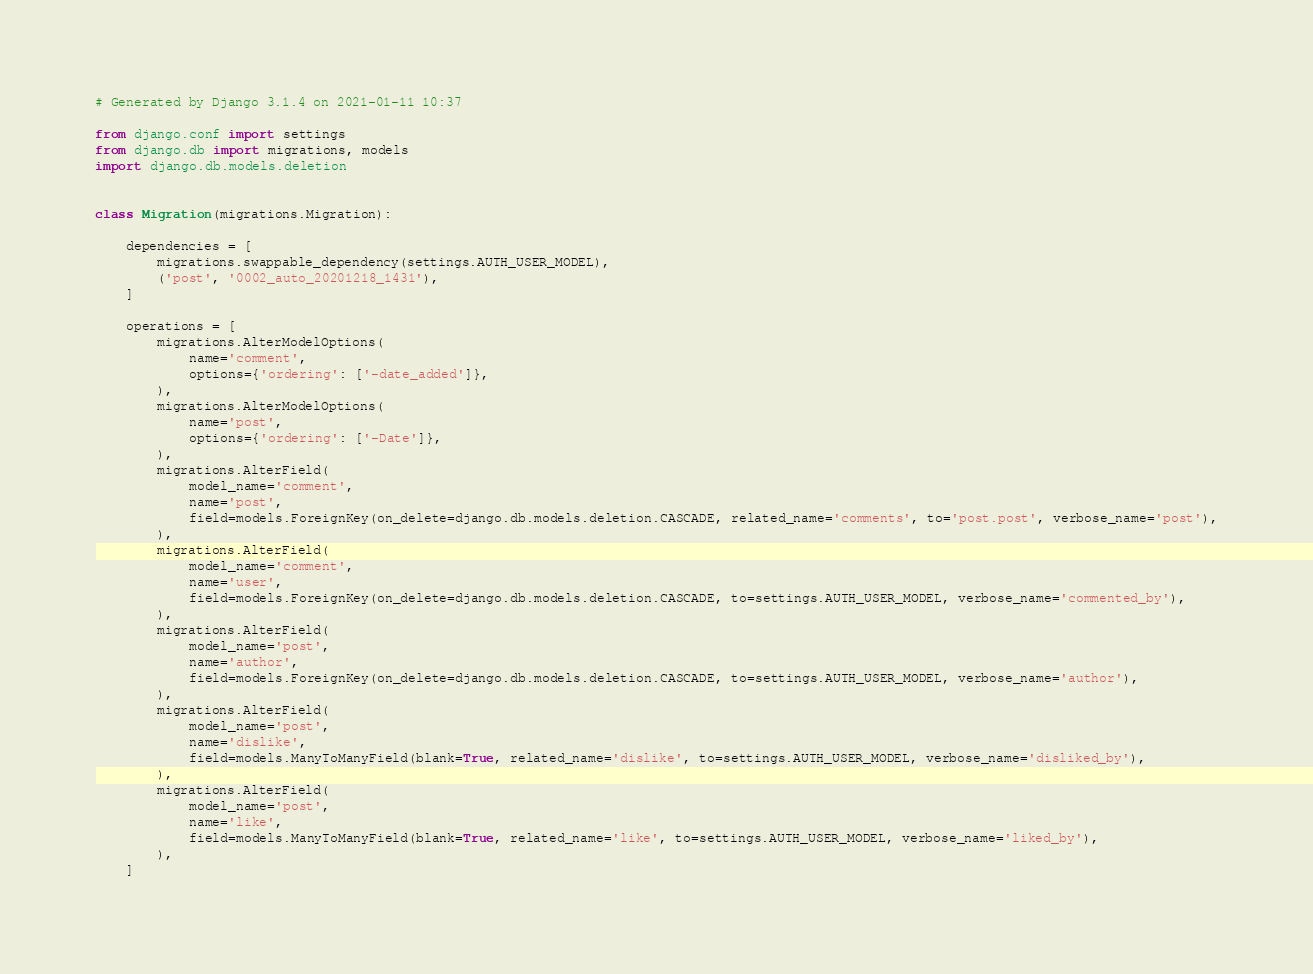<code> <loc_0><loc_0><loc_500><loc_500><_Python_># Generated by Django 3.1.4 on 2021-01-11 10:37

from django.conf import settings
from django.db import migrations, models
import django.db.models.deletion


class Migration(migrations.Migration):

    dependencies = [
        migrations.swappable_dependency(settings.AUTH_USER_MODEL),
        ('post', '0002_auto_20201218_1431'),
    ]

    operations = [
        migrations.AlterModelOptions(
            name='comment',
            options={'ordering': ['-date_added']},
        ),
        migrations.AlterModelOptions(
            name='post',
            options={'ordering': ['-Date']},
        ),
        migrations.AlterField(
            model_name='comment',
            name='post',
            field=models.ForeignKey(on_delete=django.db.models.deletion.CASCADE, related_name='comments', to='post.post', verbose_name='post'),
        ),
        migrations.AlterField(
            model_name='comment',
            name='user',
            field=models.ForeignKey(on_delete=django.db.models.deletion.CASCADE, to=settings.AUTH_USER_MODEL, verbose_name='commented_by'),
        ),
        migrations.AlterField(
            model_name='post',
            name='author',
            field=models.ForeignKey(on_delete=django.db.models.deletion.CASCADE, to=settings.AUTH_USER_MODEL, verbose_name='author'),
        ),
        migrations.AlterField(
            model_name='post',
            name='dislike',
            field=models.ManyToManyField(blank=True, related_name='dislike', to=settings.AUTH_USER_MODEL, verbose_name='disliked_by'),
        ),
        migrations.AlterField(
            model_name='post',
            name='like',
            field=models.ManyToManyField(blank=True, related_name='like', to=settings.AUTH_USER_MODEL, verbose_name='liked_by'),
        ),
    ]
</code> 